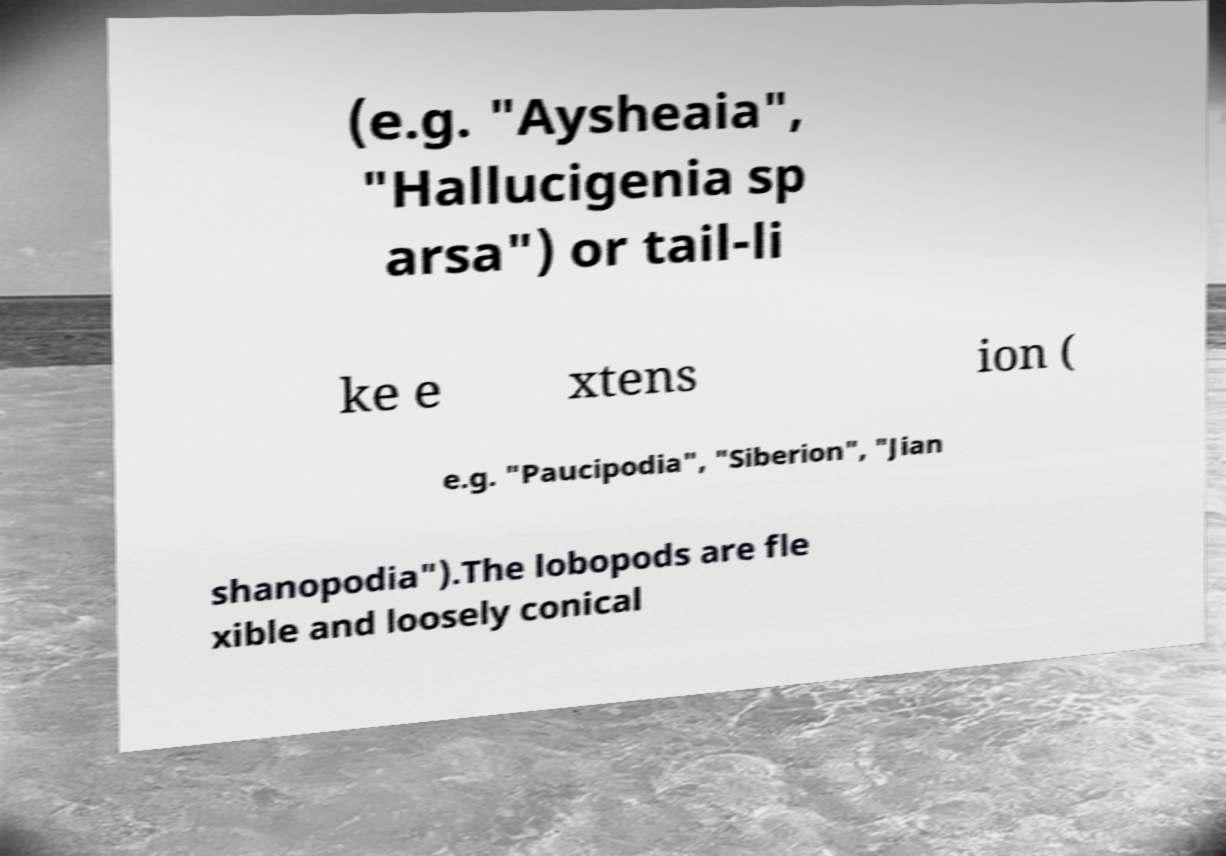Please read and relay the text visible in this image. What does it say? (e.g. "Aysheaia", "Hallucigenia sp arsa") or tail-li ke e xtens ion ( e.g. "Paucipodia", "Siberion", "Jian shanopodia").The lobopods are fle xible and loosely conical 